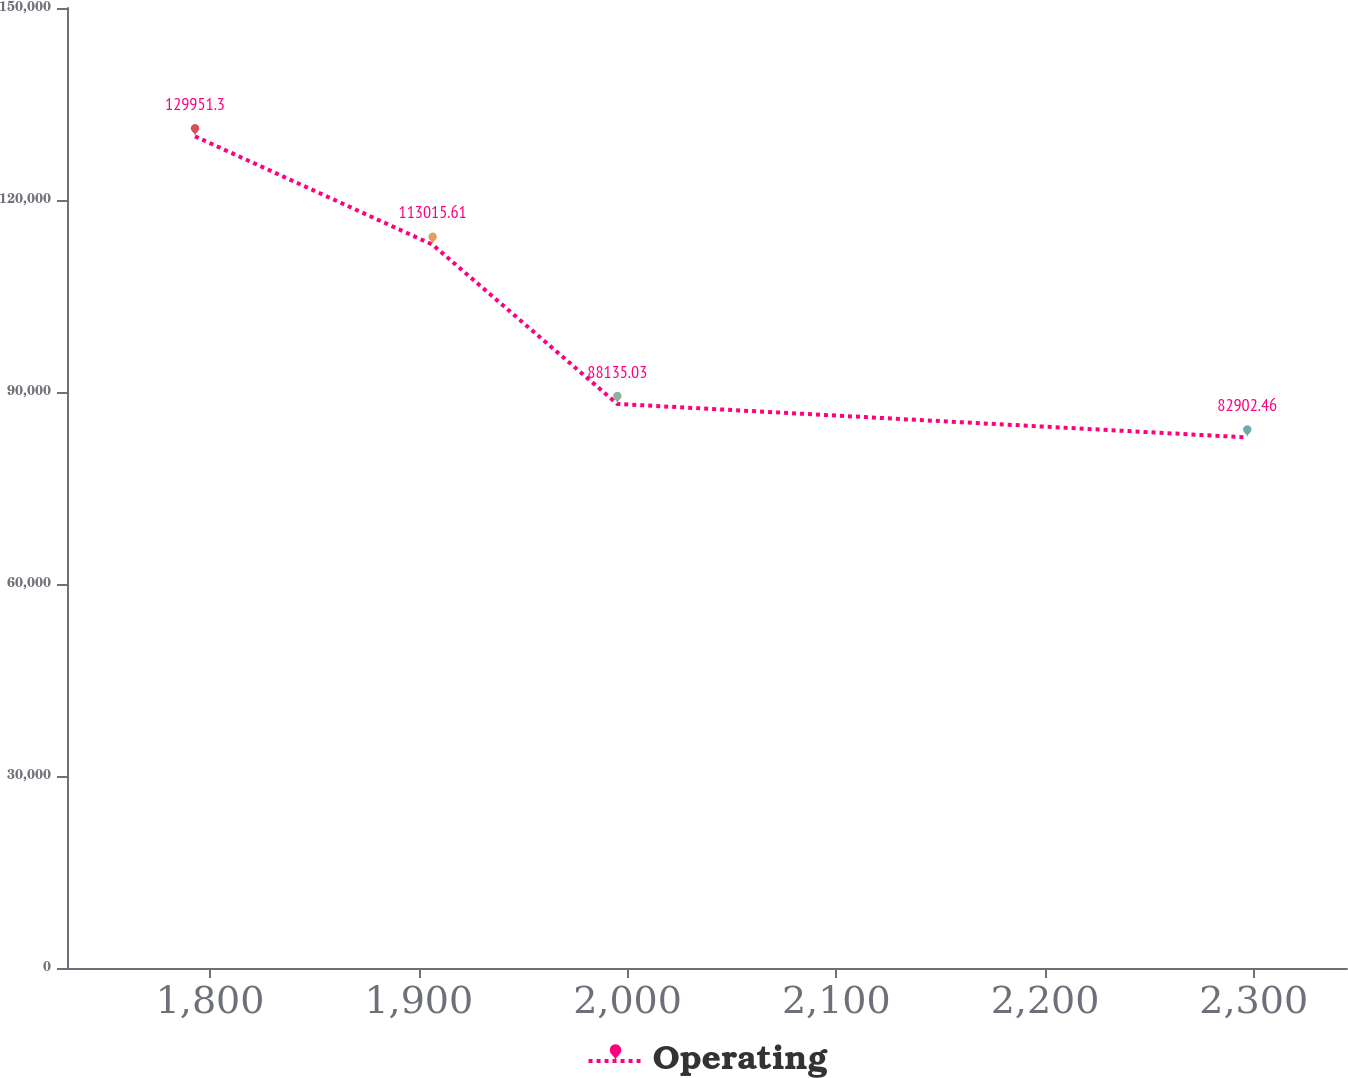Convert chart to OTSL. <chart><loc_0><loc_0><loc_500><loc_500><line_chart><ecel><fcel>Operating<nl><fcel>1792.78<fcel>129951<nl><fcel>1906.62<fcel>113016<nl><fcel>1995.1<fcel>88135<nl><fcel>2296.89<fcel>82902.5<nl><fcel>2405.99<fcel>77625.6<nl></chart> 